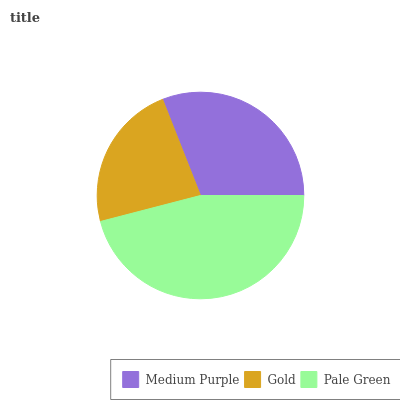Is Gold the minimum?
Answer yes or no. Yes. Is Pale Green the maximum?
Answer yes or no. Yes. Is Pale Green the minimum?
Answer yes or no. No. Is Gold the maximum?
Answer yes or no. No. Is Pale Green greater than Gold?
Answer yes or no. Yes. Is Gold less than Pale Green?
Answer yes or no. Yes. Is Gold greater than Pale Green?
Answer yes or no. No. Is Pale Green less than Gold?
Answer yes or no. No. Is Medium Purple the high median?
Answer yes or no. Yes. Is Medium Purple the low median?
Answer yes or no. Yes. Is Pale Green the high median?
Answer yes or no. No. Is Gold the low median?
Answer yes or no. No. 